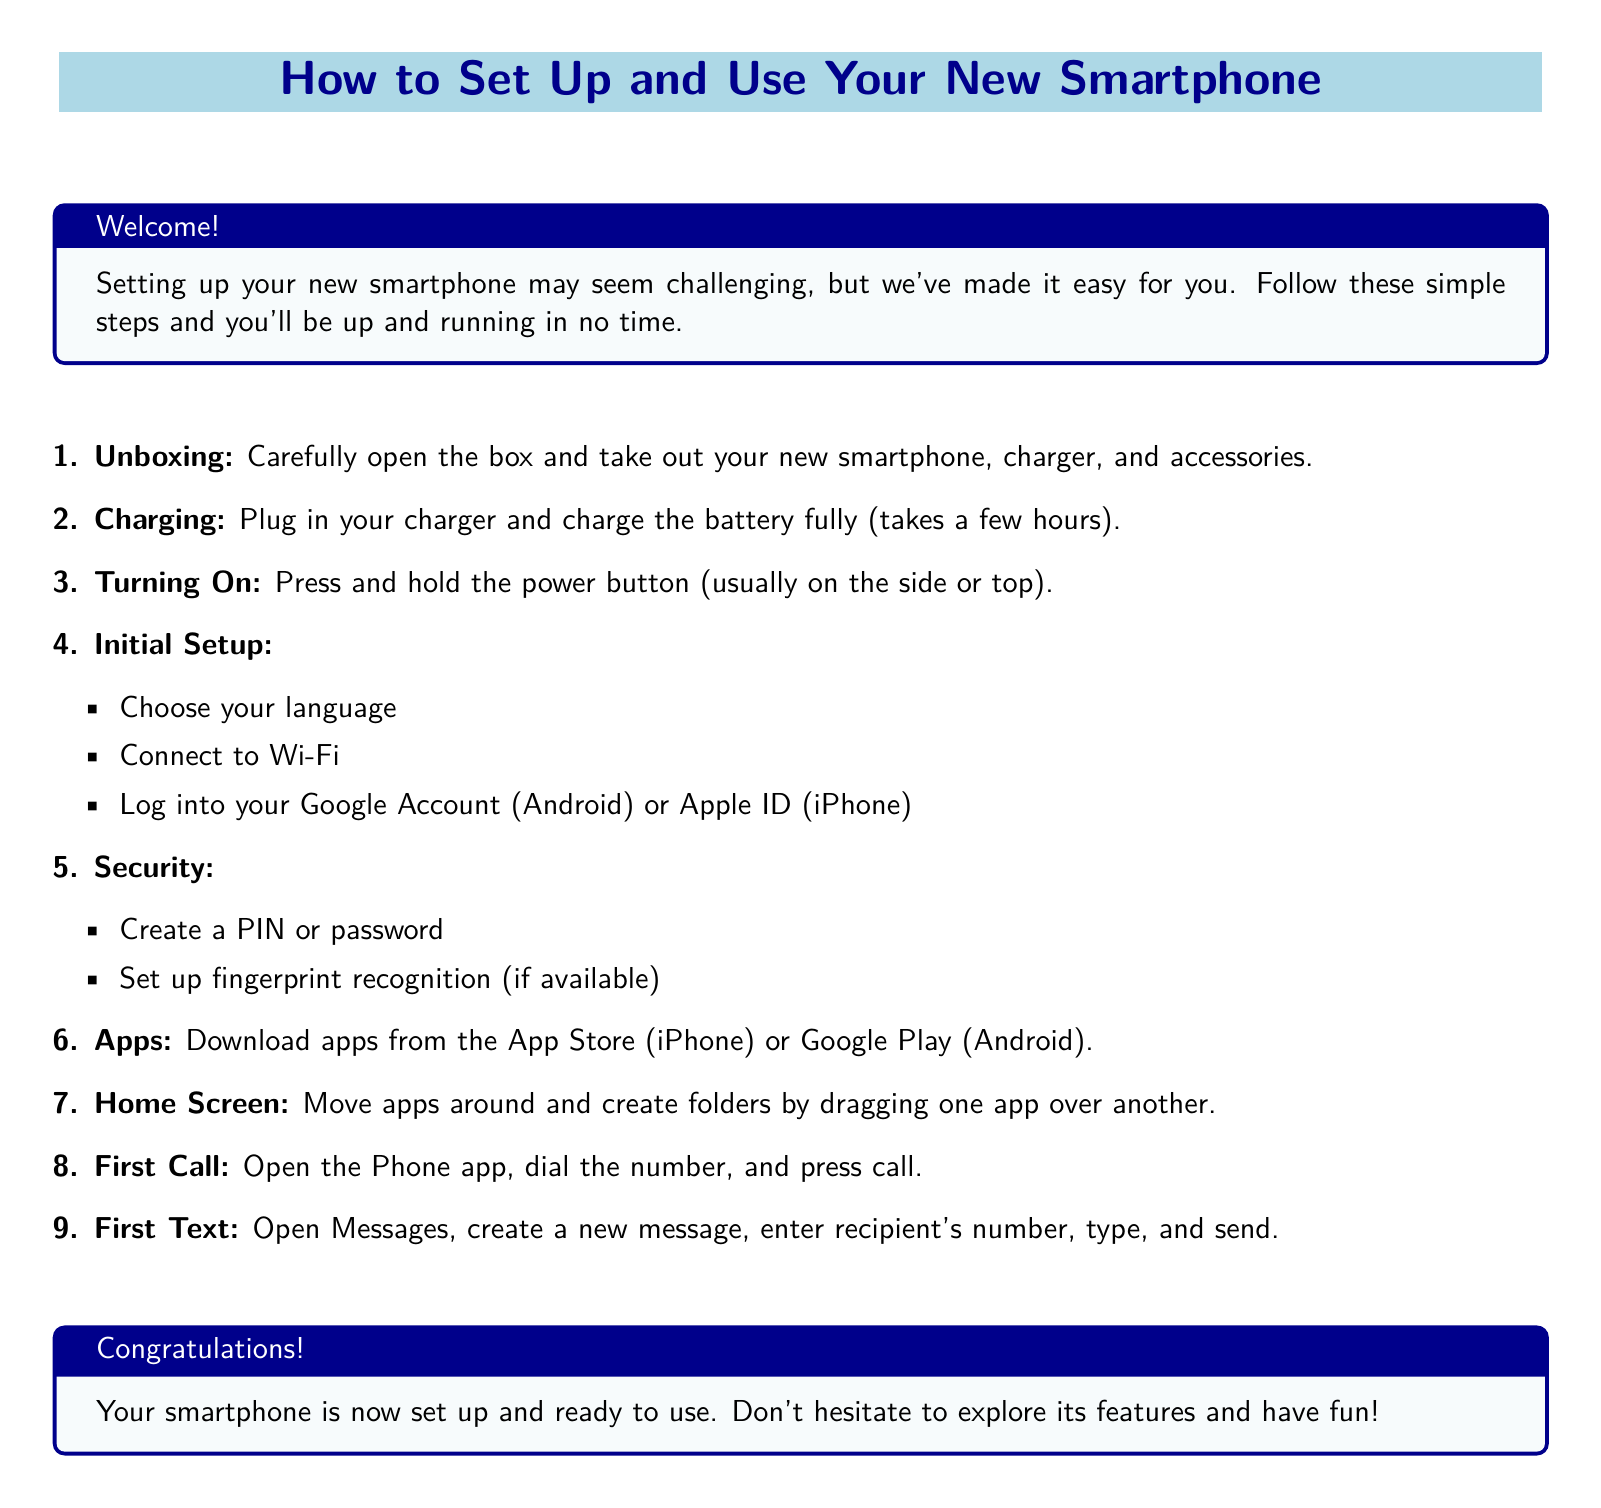What is the first step in setting up the smartphone? The first step listed in the document is "Unboxing," which involves carefully opening the box and taking out the smartphone, charger, and accessories.
Answer: Unboxing How should you charge the smartphone? The document states that you should plug in your charger and charge the battery fully, which takes a few hours.
Answer: Charge the battery fully What should you do after pressing the power button? After turning on the smartphone, you should proceed to the "Initial Setup," which involves choosing your language, connecting to Wi-Fi, and logging into your account.
Answer: Initial Setup What security feature can you set up if available? The document mentions setting up fingerprint recognition as a security feature, along with creating a PIN or password.
Answer: Fingerprint recognition What are the two app sources mentioned in the document? The document refers to the App Store for iPhone users and Google Play for Android users as app sources.
Answer: App Store and Google Play What action should be taken to make your first call? To make your first call, you need to open the Phone app, dial the number, and press call.
Answer: Open the Phone app How do you create folders on your home screen? You can create folders on your home screen by dragging one app over another.
Answer: Drag one app over another What is the main purpose of this document? The document is designed to guide users through setting up and using their new smartphones with simple steps and instructions.
Answer: User guide How does the document help with initial smartphone setup? It provides step-by-step instructions for various setup activities to make the process easier for users.
Answer: Step-by-step instructions 